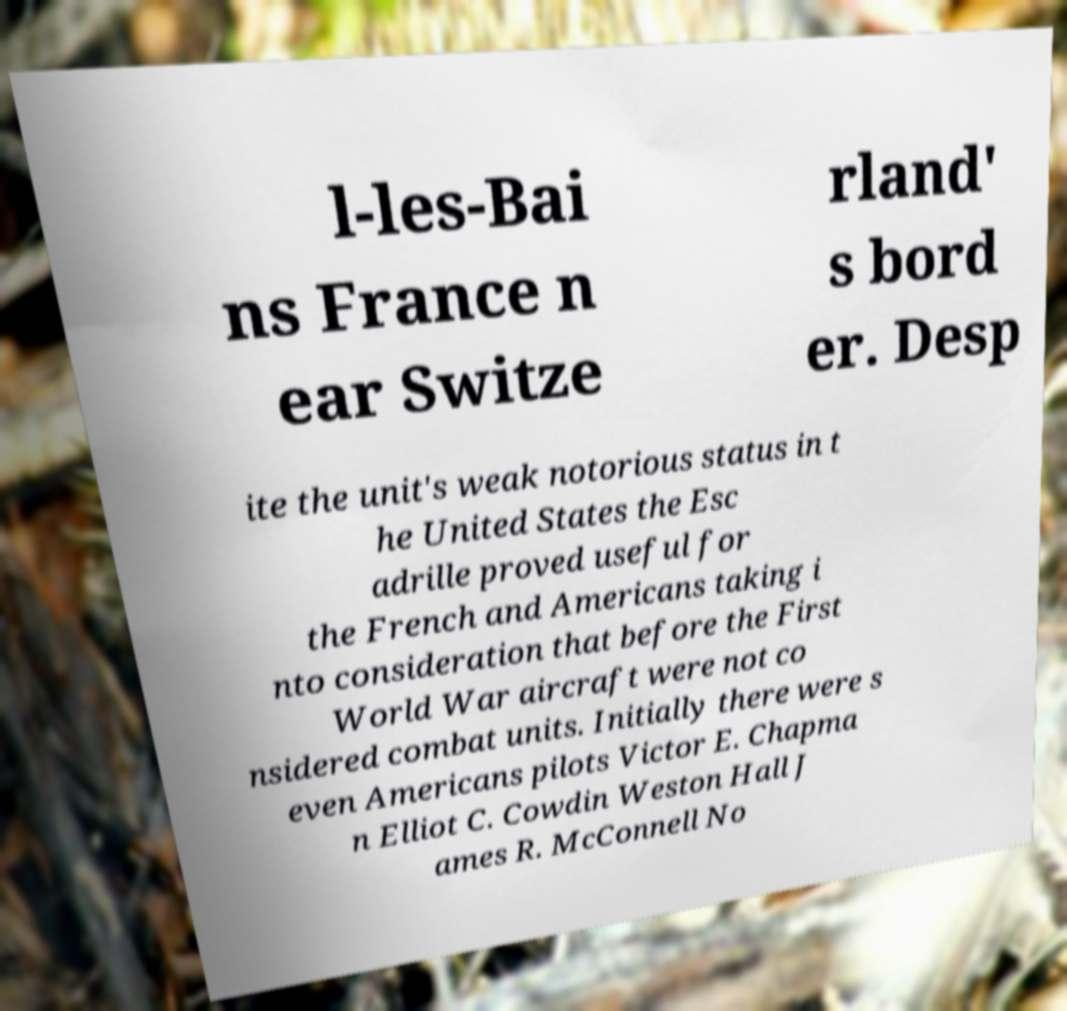What messages or text are displayed in this image? I need them in a readable, typed format. l-les-Bai ns France n ear Switze rland' s bord er. Desp ite the unit's weak notorious status in t he United States the Esc adrille proved useful for the French and Americans taking i nto consideration that before the First World War aircraft were not co nsidered combat units. Initially there were s even Americans pilots Victor E. Chapma n Elliot C. Cowdin Weston Hall J ames R. McConnell No 